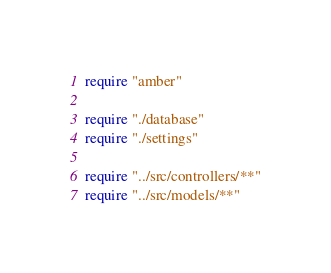Convert code to text. <code><loc_0><loc_0><loc_500><loc_500><_Crystal_>require "amber"

require "./database"
require "./settings"

require "../src/controllers/**"
require "../src/models/**"
</code> 